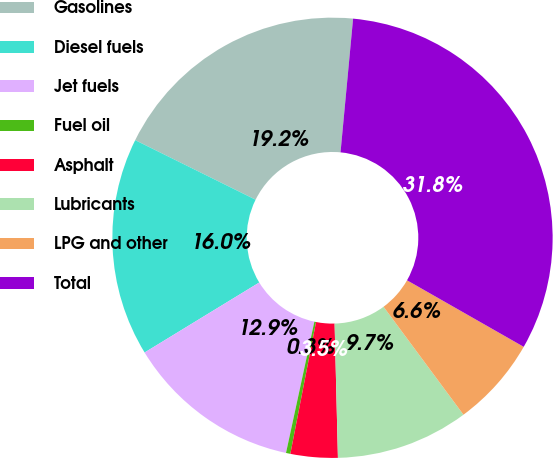Convert chart to OTSL. <chart><loc_0><loc_0><loc_500><loc_500><pie_chart><fcel>Gasolines<fcel>Diesel fuels<fcel>Jet fuels<fcel>Fuel oil<fcel>Asphalt<fcel>Lubricants<fcel>LPG and other<fcel>Total<nl><fcel>19.18%<fcel>16.04%<fcel>12.89%<fcel>0.32%<fcel>3.46%<fcel>9.75%<fcel>6.61%<fcel>31.76%<nl></chart> 